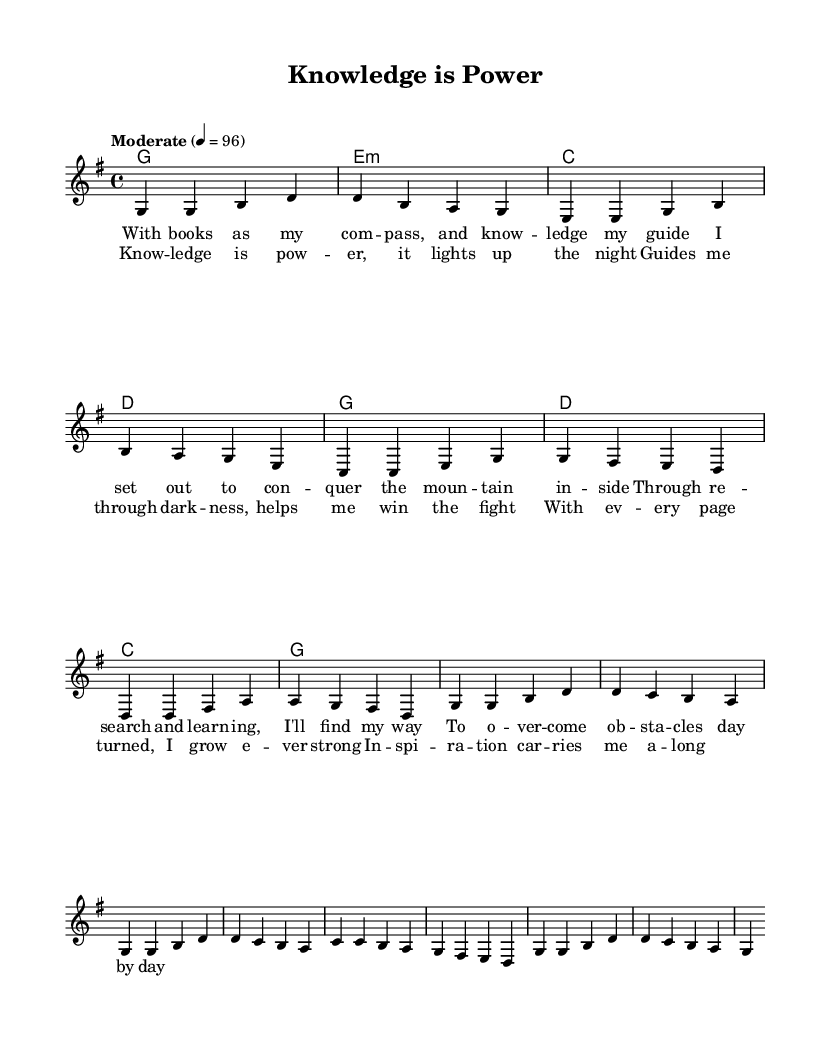What is the key signature of this music? The key signature is G major, which has one sharp (F#). This can be identified from the initial part of the sheet music where the key is marked.
Answer: G major What is the time signature of this music? The time signature shown in the music is 4/4, meaning there are four beats in a measure and the quarter note gets one beat. This is indicated at the beginning of the excerpt.
Answer: 4/4 What is the tempo marking of this music? The tempo marking is "Moderate" with a metronome marking of 96 beats per minute. This is indicated near the top of the sheet music where the tempo is specified.
Answer: Moderate 96 How many measures are in the verse? The verse consists of 8 measures, as counted from the melody section where each grouping of notes corresponds to a measure.
Answer: 8 measures What is the overall theme of the song? The overall theme of the song is about the power of knowledge and overcoming obstacles. This can be inferred from the lyrics provided, especially in the chorus and verse sections.
Answer: Power of knowledge What is the structure of the song? The song structure consists of a verse followed by a chorus, indicated in the arrangement of the music where the verse lyrics precede the chorus lyrics. This traditional structure is common in country music.
Answer: Verse, Chorus What type of chord is used during the first measure of the verse? The chord used in the first measure of the verse is G major, as indicated in the chord names section above the staff. This chord establishes the tonal center for the piece.
Answer: G major 